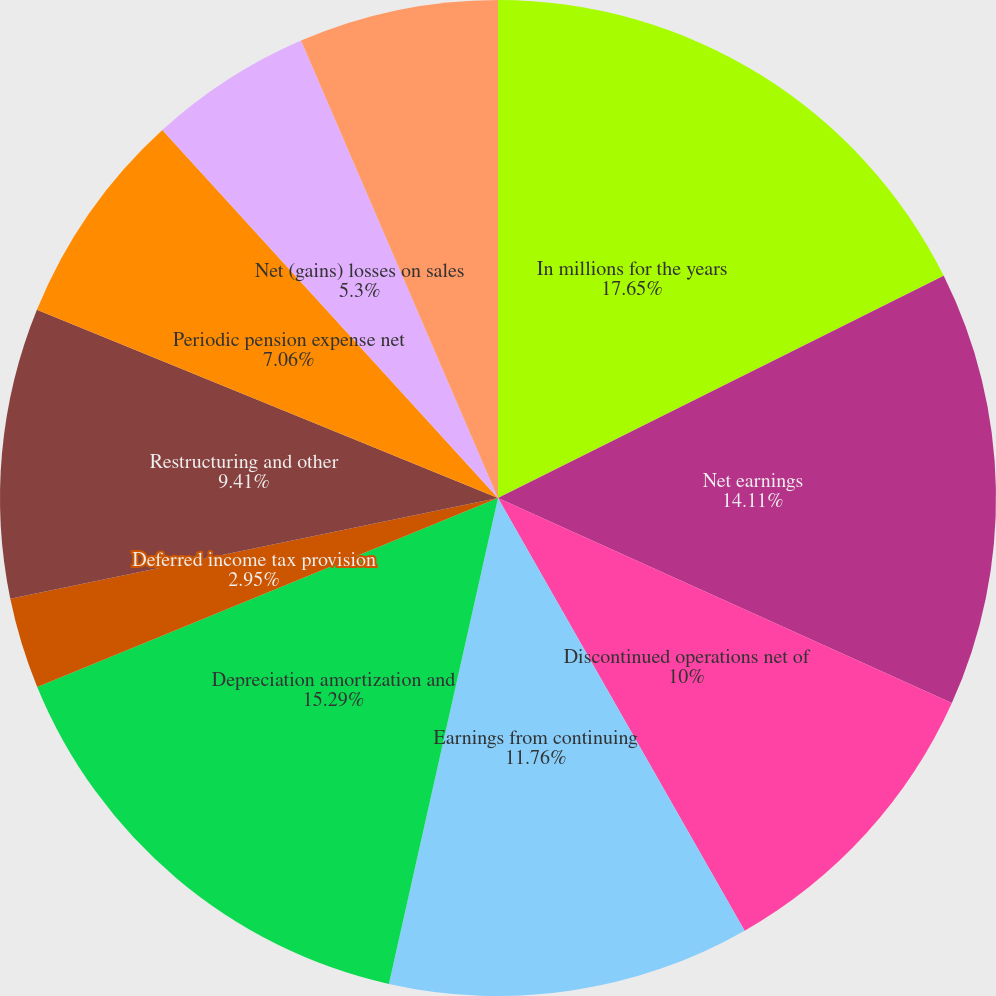Convert chart. <chart><loc_0><loc_0><loc_500><loc_500><pie_chart><fcel>In millions for the years<fcel>Net earnings<fcel>Discontinued operations net of<fcel>Earnings from continuing<fcel>Depreciation amortization and<fcel>Deferred income tax provision<fcel>Restructuring and other<fcel>Periodic pension expense net<fcel>Net (gains) losses on sales<fcel>Other net<nl><fcel>17.64%<fcel>14.11%<fcel>10.0%<fcel>11.76%<fcel>15.29%<fcel>2.95%<fcel>9.41%<fcel>7.06%<fcel>5.3%<fcel>6.47%<nl></chart> 